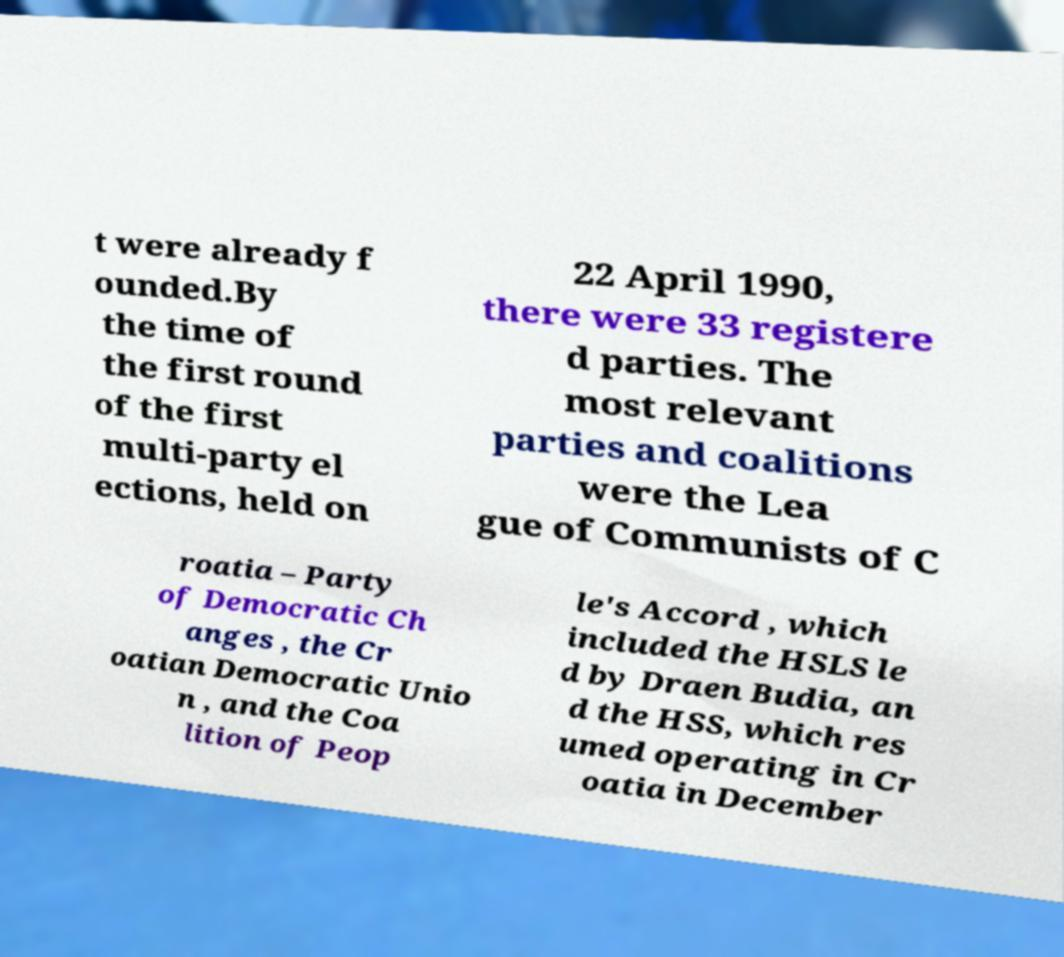Can you accurately transcribe the text from the provided image for me? t were already f ounded.By the time of the first round of the first multi-party el ections, held on 22 April 1990, there were 33 registere d parties. The most relevant parties and coalitions were the Lea gue of Communists of C roatia – Party of Democratic Ch anges , the Cr oatian Democratic Unio n , and the Coa lition of Peop le's Accord , which included the HSLS le d by Draen Budia, an d the HSS, which res umed operating in Cr oatia in December 